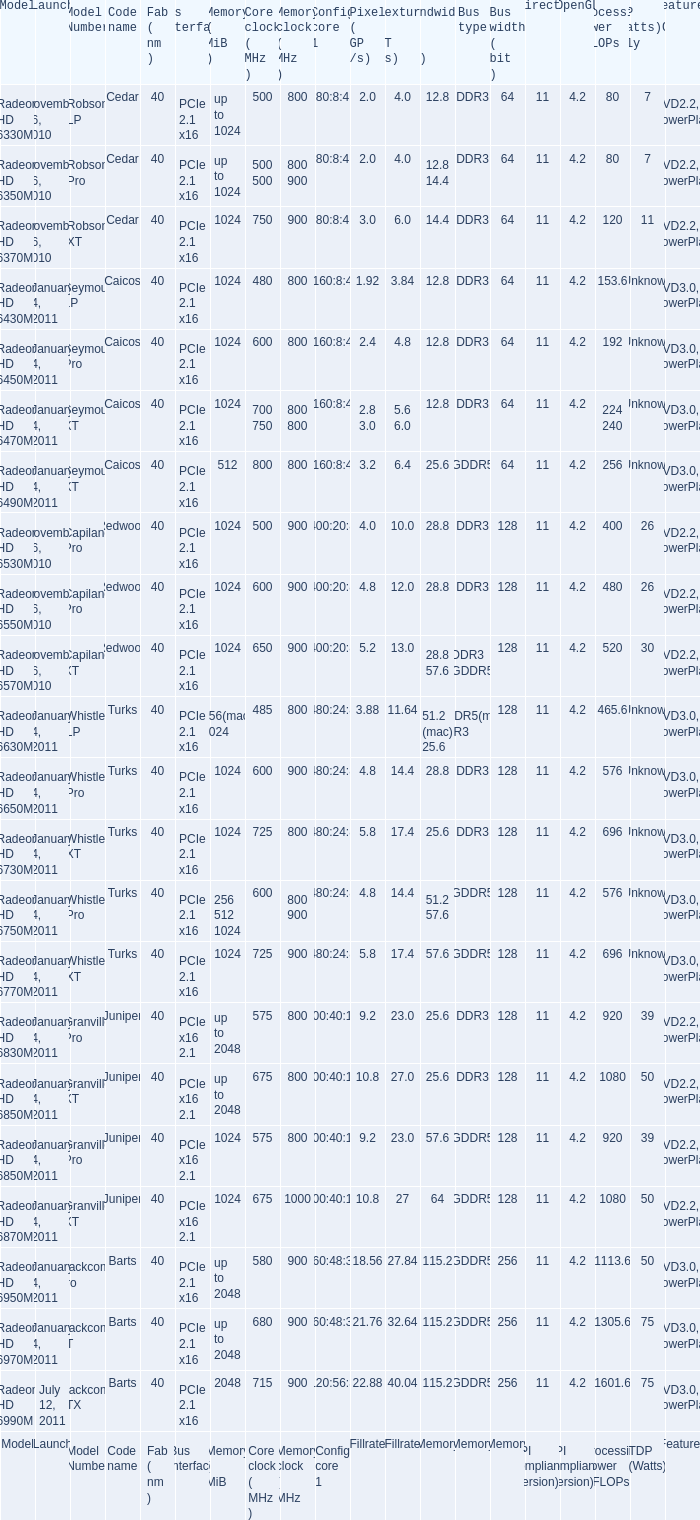How many values for bus width possess a bandwidth of 2 1.0. 